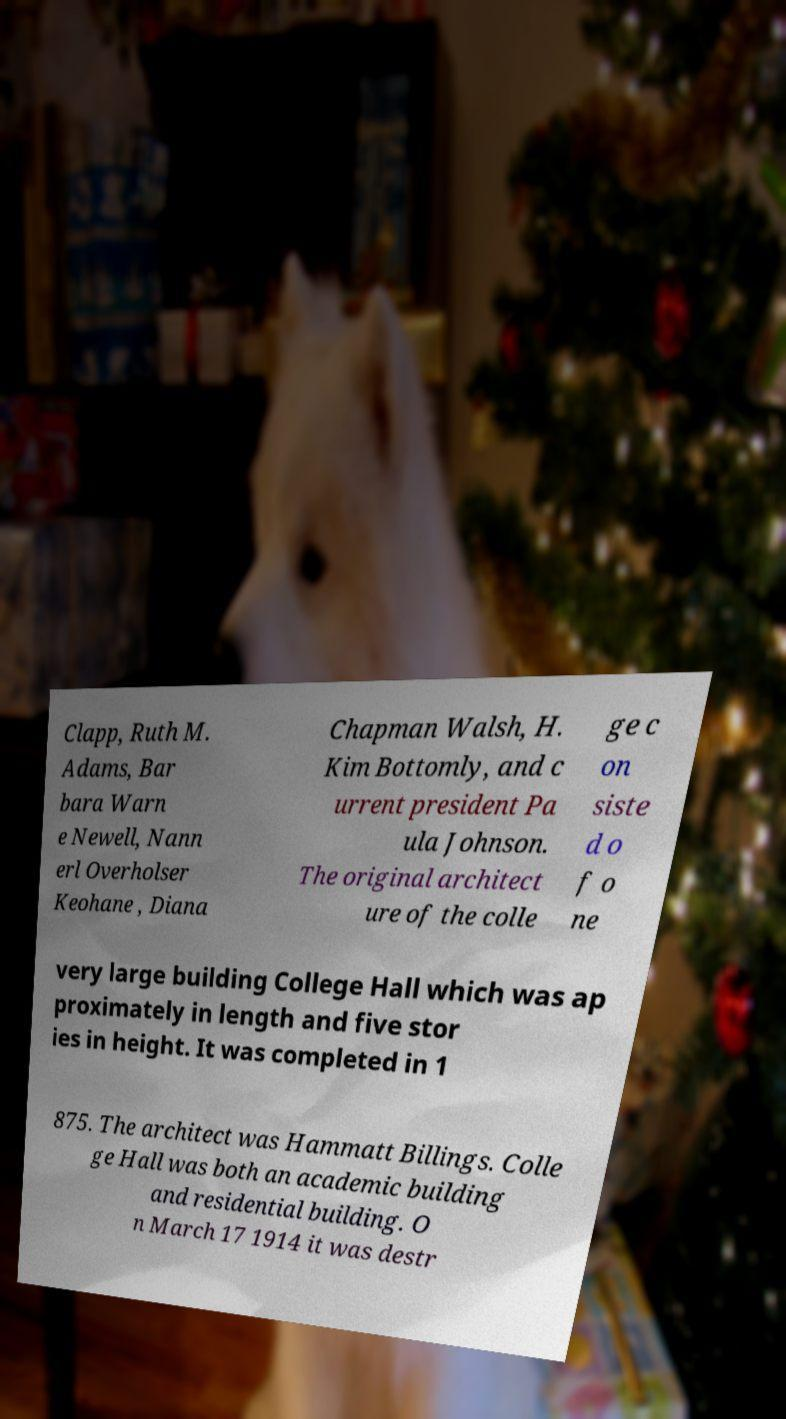I need the written content from this picture converted into text. Can you do that? Clapp, Ruth M. Adams, Bar bara Warn e Newell, Nann erl Overholser Keohane , Diana Chapman Walsh, H. Kim Bottomly, and c urrent president Pa ula Johnson. The original architect ure of the colle ge c on siste d o f o ne very large building College Hall which was ap proximately in length and five stor ies in height. It was completed in 1 875. The architect was Hammatt Billings. Colle ge Hall was both an academic building and residential building. O n March 17 1914 it was destr 